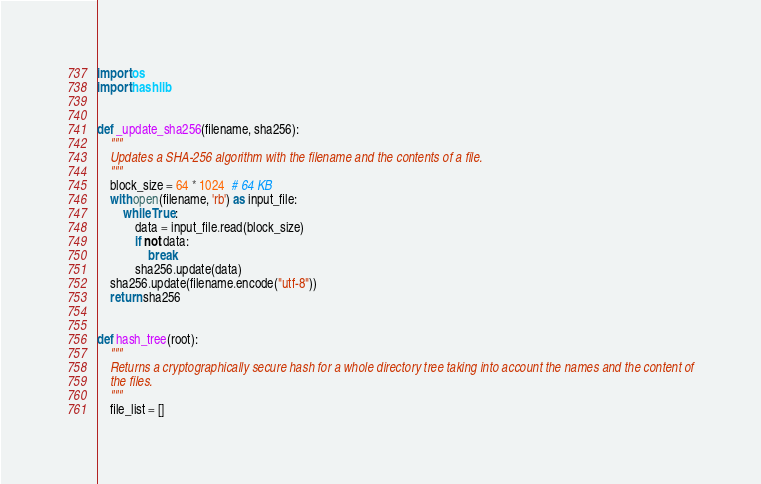Convert code to text. <code><loc_0><loc_0><loc_500><loc_500><_Python_>import os
import hashlib


def _update_sha256(filename, sha256):
    """
    Updates a SHA-256 algorithm with the filename and the contents of a file.
    """
    block_size = 64 * 1024  # 64 KB
    with open(filename, 'rb') as input_file:
        while True:
            data = input_file.read(block_size)
            if not data:
                break
            sha256.update(data)
    sha256.update(filename.encode("utf-8"))
    return sha256


def hash_tree(root):
    """
    Returns a cryptographically secure hash for a whole directory tree taking into account the names and the content of
    the files.
    """
    file_list = []</code> 